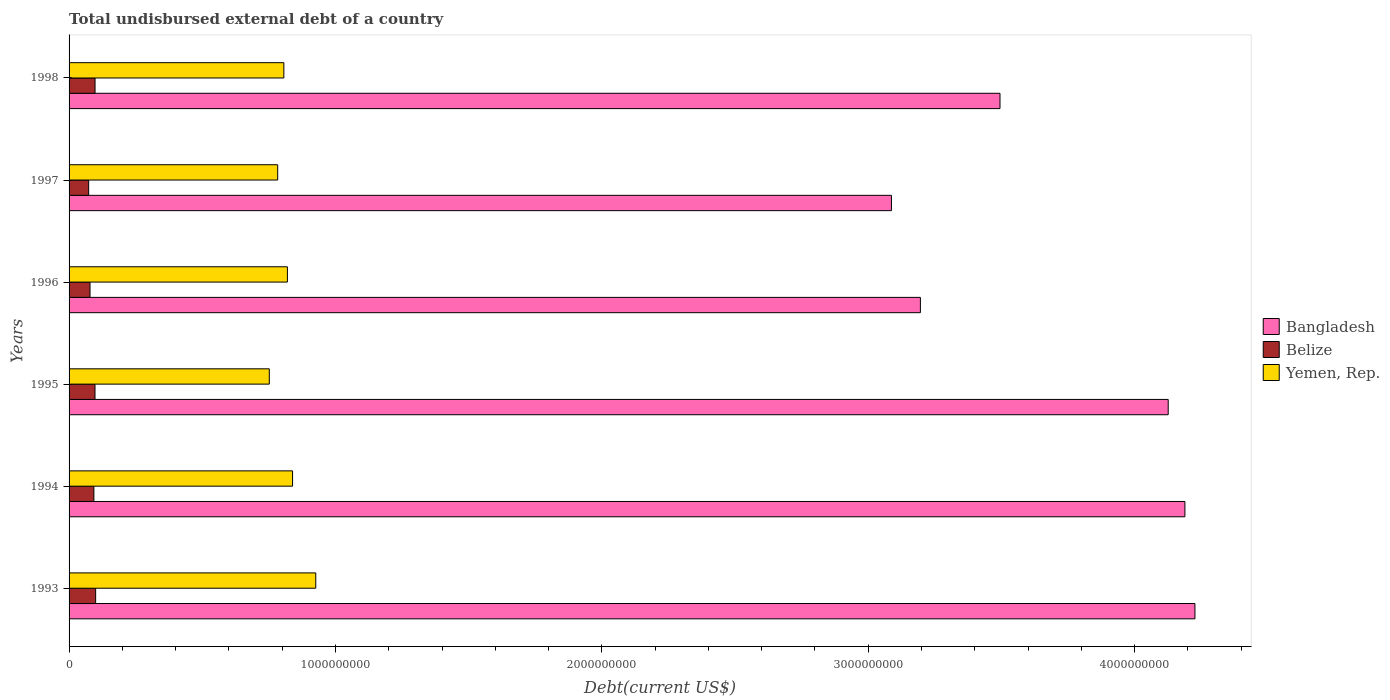How many different coloured bars are there?
Your answer should be very brief. 3. How many groups of bars are there?
Offer a terse response. 6. How many bars are there on the 3rd tick from the top?
Make the answer very short. 3. What is the total undisbursed external debt in Belize in 1998?
Provide a succinct answer. 9.75e+07. Across all years, what is the maximum total undisbursed external debt in Bangladesh?
Offer a terse response. 4.23e+09. Across all years, what is the minimum total undisbursed external debt in Yemen, Rep.?
Your answer should be compact. 7.52e+08. In which year was the total undisbursed external debt in Yemen, Rep. minimum?
Your response must be concise. 1995. What is the total total undisbursed external debt in Belize in the graph?
Ensure brevity in your answer.  5.40e+08. What is the difference between the total undisbursed external debt in Belize in 1994 and that in 1997?
Your response must be concise. 1.96e+07. What is the difference between the total undisbursed external debt in Yemen, Rep. in 1994 and the total undisbursed external debt in Belize in 1995?
Your answer should be compact. 7.42e+08. What is the average total undisbursed external debt in Belize per year?
Offer a terse response. 9.00e+07. In the year 1995, what is the difference between the total undisbursed external debt in Bangladesh and total undisbursed external debt in Belize?
Offer a very short reply. 4.03e+09. In how many years, is the total undisbursed external debt in Belize greater than 4200000000 US$?
Provide a short and direct response. 0. What is the ratio of the total undisbursed external debt in Yemen, Rep. in 1996 to that in 1998?
Your response must be concise. 1.02. Is the total undisbursed external debt in Bangladesh in 1996 less than that in 1998?
Offer a terse response. Yes. Is the difference between the total undisbursed external debt in Bangladesh in 1995 and 1997 greater than the difference between the total undisbursed external debt in Belize in 1995 and 1997?
Offer a very short reply. Yes. What is the difference between the highest and the second highest total undisbursed external debt in Bangladesh?
Ensure brevity in your answer.  3.77e+07. What is the difference between the highest and the lowest total undisbursed external debt in Yemen, Rep.?
Your answer should be compact. 1.74e+08. In how many years, is the total undisbursed external debt in Belize greater than the average total undisbursed external debt in Belize taken over all years?
Your response must be concise. 4. Is the sum of the total undisbursed external debt in Bangladesh in 1996 and 1998 greater than the maximum total undisbursed external debt in Belize across all years?
Ensure brevity in your answer.  Yes. What does the 1st bar from the top in 1995 represents?
Provide a succinct answer. Yemen, Rep. What does the 3rd bar from the bottom in 1997 represents?
Give a very brief answer. Yemen, Rep. How many bars are there?
Keep it short and to the point. 18. Are all the bars in the graph horizontal?
Ensure brevity in your answer.  Yes. How many years are there in the graph?
Give a very brief answer. 6. What is the difference between two consecutive major ticks on the X-axis?
Offer a terse response. 1.00e+09. Are the values on the major ticks of X-axis written in scientific E-notation?
Make the answer very short. No. Where does the legend appear in the graph?
Your answer should be very brief. Center right. How many legend labels are there?
Offer a terse response. 3. What is the title of the graph?
Ensure brevity in your answer.  Total undisbursed external debt of a country. Does "Madagascar" appear as one of the legend labels in the graph?
Offer a very short reply. No. What is the label or title of the X-axis?
Provide a succinct answer. Debt(current US$). What is the label or title of the Y-axis?
Provide a succinct answer. Years. What is the Debt(current US$) of Bangladesh in 1993?
Offer a terse response. 4.23e+09. What is the Debt(current US$) in Belize in 1993?
Your response must be concise. 9.97e+07. What is the Debt(current US$) of Yemen, Rep. in 1993?
Provide a succinct answer. 9.26e+08. What is the Debt(current US$) in Bangladesh in 1994?
Ensure brevity in your answer.  4.19e+09. What is the Debt(current US$) of Belize in 1994?
Your response must be concise. 9.31e+07. What is the Debt(current US$) in Yemen, Rep. in 1994?
Offer a very short reply. 8.39e+08. What is the Debt(current US$) in Bangladesh in 1995?
Your answer should be very brief. 4.13e+09. What is the Debt(current US$) in Belize in 1995?
Your response must be concise. 9.73e+07. What is the Debt(current US$) of Yemen, Rep. in 1995?
Provide a short and direct response. 7.52e+08. What is the Debt(current US$) of Bangladesh in 1996?
Offer a terse response. 3.20e+09. What is the Debt(current US$) of Belize in 1996?
Offer a terse response. 7.87e+07. What is the Debt(current US$) of Yemen, Rep. in 1996?
Offer a very short reply. 8.20e+08. What is the Debt(current US$) in Bangladesh in 1997?
Offer a terse response. 3.09e+09. What is the Debt(current US$) in Belize in 1997?
Keep it short and to the point. 7.35e+07. What is the Debt(current US$) of Yemen, Rep. in 1997?
Give a very brief answer. 7.83e+08. What is the Debt(current US$) in Bangladesh in 1998?
Your answer should be compact. 3.49e+09. What is the Debt(current US$) in Belize in 1998?
Provide a succinct answer. 9.75e+07. What is the Debt(current US$) in Yemen, Rep. in 1998?
Make the answer very short. 8.06e+08. Across all years, what is the maximum Debt(current US$) in Bangladesh?
Your response must be concise. 4.23e+09. Across all years, what is the maximum Debt(current US$) of Belize?
Make the answer very short. 9.97e+07. Across all years, what is the maximum Debt(current US$) of Yemen, Rep.?
Keep it short and to the point. 9.26e+08. Across all years, what is the minimum Debt(current US$) in Bangladesh?
Provide a short and direct response. 3.09e+09. Across all years, what is the minimum Debt(current US$) of Belize?
Ensure brevity in your answer.  7.35e+07. Across all years, what is the minimum Debt(current US$) in Yemen, Rep.?
Your answer should be very brief. 7.52e+08. What is the total Debt(current US$) in Bangladesh in the graph?
Your answer should be compact. 2.23e+1. What is the total Debt(current US$) in Belize in the graph?
Ensure brevity in your answer.  5.40e+08. What is the total Debt(current US$) in Yemen, Rep. in the graph?
Provide a short and direct response. 4.93e+09. What is the difference between the Debt(current US$) in Bangladesh in 1993 and that in 1994?
Offer a terse response. 3.77e+07. What is the difference between the Debt(current US$) in Belize in 1993 and that in 1994?
Offer a terse response. 6.62e+06. What is the difference between the Debt(current US$) of Yemen, Rep. in 1993 and that in 1994?
Give a very brief answer. 8.71e+07. What is the difference between the Debt(current US$) in Bangladesh in 1993 and that in 1995?
Ensure brevity in your answer.  1.00e+08. What is the difference between the Debt(current US$) in Belize in 1993 and that in 1995?
Keep it short and to the point. 2.42e+06. What is the difference between the Debt(current US$) in Yemen, Rep. in 1993 and that in 1995?
Offer a very short reply. 1.74e+08. What is the difference between the Debt(current US$) of Bangladesh in 1993 and that in 1996?
Keep it short and to the point. 1.03e+09. What is the difference between the Debt(current US$) of Belize in 1993 and that in 1996?
Keep it short and to the point. 2.11e+07. What is the difference between the Debt(current US$) of Yemen, Rep. in 1993 and that in 1996?
Provide a succinct answer. 1.06e+08. What is the difference between the Debt(current US$) of Bangladesh in 1993 and that in 1997?
Provide a short and direct response. 1.14e+09. What is the difference between the Debt(current US$) of Belize in 1993 and that in 1997?
Your response must be concise. 2.62e+07. What is the difference between the Debt(current US$) in Yemen, Rep. in 1993 and that in 1997?
Ensure brevity in your answer.  1.43e+08. What is the difference between the Debt(current US$) in Bangladesh in 1993 and that in 1998?
Offer a very short reply. 7.32e+08. What is the difference between the Debt(current US$) in Belize in 1993 and that in 1998?
Ensure brevity in your answer.  2.23e+06. What is the difference between the Debt(current US$) of Yemen, Rep. in 1993 and that in 1998?
Your answer should be very brief. 1.20e+08. What is the difference between the Debt(current US$) of Bangladesh in 1994 and that in 1995?
Your response must be concise. 6.27e+07. What is the difference between the Debt(current US$) of Belize in 1994 and that in 1995?
Your answer should be very brief. -4.20e+06. What is the difference between the Debt(current US$) of Yemen, Rep. in 1994 and that in 1995?
Provide a succinct answer. 8.74e+07. What is the difference between the Debt(current US$) of Bangladesh in 1994 and that in 1996?
Ensure brevity in your answer.  9.93e+08. What is the difference between the Debt(current US$) of Belize in 1994 and that in 1996?
Ensure brevity in your answer.  1.45e+07. What is the difference between the Debt(current US$) of Yemen, Rep. in 1994 and that in 1996?
Offer a terse response. 1.94e+07. What is the difference between the Debt(current US$) in Bangladesh in 1994 and that in 1997?
Provide a succinct answer. 1.10e+09. What is the difference between the Debt(current US$) in Belize in 1994 and that in 1997?
Your answer should be very brief. 1.96e+07. What is the difference between the Debt(current US$) of Yemen, Rep. in 1994 and that in 1997?
Your answer should be compact. 5.59e+07. What is the difference between the Debt(current US$) of Bangladesh in 1994 and that in 1998?
Provide a succinct answer. 6.94e+08. What is the difference between the Debt(current US$) in Belize in 1994 and that in 1998?
Your response must be concise. -4.39e+06. What is the difference between the Debt(current US$) in Yemen, Rep. in 1994 and that in 1998?
Make the answer very short. 3.27e+07. What is the difference between the Debt(current US$) of Bangladesh in 1995 and that in 1996?
Give a very brief answer. 9.30e+08. What is the difference between the Debt(current US$) in Belize in 1995 and that in 1996?
Your response must be concise. 1.87e+07. What is the difference between the Debt(current US$) of Yemen, Rep. in 1995 and that in 1996?
Offer a terse response. -6.80e+07. What is the difference between the Debt(current US$) of Bangladesh in 1995 and that in 1997?
Make the answer very short. 1.04e+09. What is the difference between the Debt(current US$) of Belize in 1995 and that in 1997?
Your answer should be very brief. 2.38e+07. What is the difference between the Debt(current US$) in Yemen, Rep. in 1995 and that in 1997?
Your answer should be very brief. -3.15e+07. What is the difference between the Debt(current US$) of Bangladesh in 1995 and that in 1998?
Your answer should be very brief. 6.31e+08. What is the difference between the Debt(current US$) of Belize in 1995 and that in 1998?
Provide a succinct answer. -1.91e+05. What is the difference between the Debt(current US$) in Yemen, Rep. in 1995 and that in 1998?
Keep it short and to the point. -5.47e+07. What is the difference between the Debt(current US$) in Bangladesh in 1996 and that in 1997?
Make the answer very short. 1.09e+08. What is the difference between the Debt(current US$) of Belize in 1996 and that in 1997?
Provide a succinct answer. 5.10e+06. What is the difference between the Debt(current US$) of Yemen, Rep. in 1996 and that in 1997?
Your answer should be compact. 3.65e+07. What is the difference between the Debt(current US$) in Bangladesh in 1996 and that in 1998?
Keep it short and to the point. -2.99e+08. What is the difference between the Debt(current US$) of Belize in 1996 and that in 1998?
Keep it short and to the point. -1.89e+07. What is the difference between the Debt(current US$) in Yemen, Rep. in 1996 and that in 1998?
Give a very brief answer. 1.33e+07. What is the difference between the Debt(current US$) in Bangladesh in 1997 and that in 1998?
Your answer should be very brief. -4.07e+08. What is the difference between the Debt(current US$) of Belize in 1997 and that in 1998?
Offer a very short reply. -2.40e+07. What is the difference between the Debt(current US$) of Yemen, Rep. in 1997 and that in 1998?
Offer a terse response. -2.32e+07. What is the difference between the Debt(current US$) in Bangladesh in 1993 and the Debt(current US$) in Belize in 1994?
Your answer should be compact. 4.13e+09. What is the difference between the Debt(current US$) of Bangladesh in 1993 and the Debt(current US$) of Yemen, Rep. in 1994?
Give a very brief answer. 3.39e+09. What is the difference between the Debt(current US$) of Belize in 1993 and the Debt(current US$) of Yemen, Rep. in 1994?
Offer a very short reply. -7.39e+08. What is the difference between the Debt(current US$) in Bangladesh in 1993 and the Debt(current US$) in Belize in 1995?
Your answer should be very brief. 4.13e+09. What is the difference between the Debt(current US$) of Bangladesh in 1993 and the Debt(current US$) of Yemen, Rep. in 1995?
Offer a terse response. 3.47e+09. What is the difference between the Debt(current US$) in Belize in 1993 and the Debt(current US$) in Yemen, Rep. in 1995?
Make the answer very short. -6.52e+08. What is the difference between the Debt(current US$) of Bangladesh in 1993 and the Debt(current US$) of Belize in 1996?
Provide a succinct answer. 4.15e+09. What is the difference between the Debt(current US$) in Bangladesh in 1993 and the Debt(current US$) in Yemen, Rep. in 1996?
Your response must be concise. 3.41e+09. What is the difference between the Debt(current US$) in Belize in 1993 and the Debt(current US$) in Yemen, Rep. in 1996?
Make the answer very short. -7.20e+08. What is the difference between the Debt(current US$) in Bangladesh in 1993 and the Debt(current US$) in Belize in 1997?
Your answer should be compact. 4.15e+09. What is the difference between the Debt(current US$) of Bangladesh in 1993 and the Debt(current US$) of Yemen, Rep. in 1997?
Keep it short and to the point. 3.44e+09. What is the difference between the Debt(current US$) in Belize in 1993 and the Debt(current US$) in Yemen, Rep. in 1997?
Provide a short and direct response. -6.83e+08. What is the difference between the Debt(current US$) in Bangladesh in 1993 and the Debt(current US$) in Belize in 1998?
Provide a succinct answer. 4.13e+09. What is the difference between the Debt(current US$) in Bangladesh in 1993 and the Debt(current US$) in Yemen, Rep. in 1998?
Keep it short and to the point. 3.42e+09. What is the difference between the Debt(current US$) of Belize in 1993 and the Debt(current US$) of Yemen, Rep. in 1998?
Provide a succinct answer. -7.07e+08. What is the difference between the Debt(current US$) of Bangladesh in 1994 and the Debt(current US$) of Belize in 1995?
Provide a short and direct response. 4.09e+09. What is the difference between the Debt(current US$) of Bangladesh in 1994 and the Debt(current US$) of Yemen, Rep. in 1995?
Provide a short and direct response. 3.44e+09. What is the difference between the Debt(current US$) in Belize in 1994 and the Debt(current US$) in Yemen, Rep. in 1995?
Your answer should be very brief. -6.59e+08. What is the difference between the Debt(current US$) in Bangladesh in 1994 and the Debt(current US$) in Belize in 1996?
Your response must be concise. 4.11e+09. What is the difference between the Debt(current US$) in Bangladesh in 1994 and the Debt(current US$) in Yemen, Rep. in 1996?
Offer a terse response. 3.37e+09. What is the difference between the Debt(current US$) in Belize in 1994 and the Debt(current US$) in Yemen, Rep. in 1996?
Keep it short and to the point. -7.27e+08. What is the difference between the Debt(current US$) in Bangladesh in 1994 and the Debt(current US$) in Belize in 1997?
Provide a short and direct response. 4.12e+09. What is the difference between the Debt(current US$) of Bangladesh in 1994 and the Debt(current US$) of Yemen, Rep. in 1997?
Provide a succinct answer. 3.41e+09. What is the difference between the Debt(current US$) of Belize in 1994 and the Debt(current US$) of Yemen, Rep. in 1997?
Make the answer very short. -6.90e+08. What is the difference between the Debt(current US$) of Bangladesh in 1994 and the Debt(current US$) of Belize in 1998?
Make the answer very short. 4.09e+09. What is the difference between the Debt(current US$) of Bangladesh in 1994 and the Debt(current US$) of Yemen, Rep. in 1998?
Give a very brief answer. 3.38e+09. What is the difference between the Debt(current US$) of Belize in 1994 and the Debt(current US$) of Yemen, Rep. in 1998?
Your response must be concise. -7.13e+08. What is the difference between the Debt(current US$) of Bangladesh in 1995 and the Debt(current US$) of Belize in 1996?
Your response must be concise. 4.05e+09. What is the difference between the Debt(current US$) of Bangladesh in 1995 and the Debt(current US$) of Yemen, Rep. in 1996?
Provide a succinct answer. 3.31e+09. What is the difference between the Debt(current US$) in Belize in 1995 and the Debt(current US$) in Yemen, Rep. in 1996?
Your answer should be very brief. -7.22e+08. What is the difference between the Debt(current US$) of Bangladesh in 1995 and the Debt(current US$) of Belize in 1997?
Your answer should be very brief. 4.05e+09. What is the difference between the Debt(current US$) of Bangladesh in 1995 and the Debt(current US$) of Yemen, Rep. in 1997?
Provide a short and direct response. 3.34e+09. What is the difference between the Debt(current US$) in Belize in 1995 and the Debt(current US$) in Yemen, Rep. in 1997?
Keep it short and to the point. -6.86e+08. What is the difference between the Debt(current US$) in Bangladesh in 1995 and the Debt(current US$) in Belize in 1998?
Keep it short and to the point. 4.03e+09. What is the difference between the Debt(current US$) of Bangladesh in 1995 and the Debt(current US$) of Yemen, Rep. in 1998?
Your response must be concise. 3.32e+09. What is the difference between the Debt(current US$) in Belize in 1995 and the Debt(current US$) in Yemen, Rep. in 1998?
Offer a terse response. -7.09e+08. What is the difference between the Debt(current US$) of Bangladesh in 1996 and the Debt(current US$) of Belize in 1997?
Offer a terse response. 3.12e+09. What is the difference between the Debt(current US$) of Bangladesh in 1996 and the Debt(current US$) of Yemen, Rep. in 1997?
Your answer should be very brief. 2.41e+09. What is the difference between the Debt(current US$) in Belize in 1996 and the Debt(current US$) in Yemen, Rep. in 1997?
Make the answer very short. -7.05e+08. What is the difference between the Debt(current US$) of Bangladesh in 1996 and the Debt(current US$) of Belize in 1998?
Ensure brevity in your answer.  3.10e+09. What is the difference between the Debt(current US$) of Bangladesh in 1996 and the Debt(current US$) of Yemen, Rep. in 1998?
Give a very brief answer. 2.39e+09. What is the difference between the Debt(current US$) of Belize in 1996 and the Debt(current US$) of Yemen, Rep. in 1998?
Your answer should be compact. -7.28e+08. What is the difference between the Debt(current US$) of Bangladesh in 1997 and the Debt(current US$) of Belize in 1998?
Keep it short and to the point. 2.99e+09. What is the difference between the Debt(current US$) of Bangladesh in 1997 and the Debt(current US$) of Yemen, Rep. in 1998?
Your answer should be compact. 2.28e+09. What is the difference between the Debt(current US$) in Belize in 1997 and the Debt(current US$) in Yemen, Rep. in 1998?
Make the answer very short. -7.33e+08. What is the average Debt(current US$) in Bangladesh per year?
Ensure brevity in your answer.  3.72e+09. What is the average Debt(current US$) of Belize per year?
Keep it short and to the point. 9.00e+07. What is the average Debt(current US$) in Yemen, Rep. per year?
Offer a very short reply. 8.21e+08. In the year 1993, what is the difference between the Debt(current US$) of Bangladesh and Debt(current US$) of Belize?
Provide a succinct answer. 4.13e+09. In the year 1993, what is the difference between the Debt(current US$) of Bangladesh and Debt(current US$) of Yemen, Rep.?
Make the answer very short. 3.30e+09. In the year 1993, what is the difference between the Debt(current US$) in Belize and Debt(current US$) in Yemen, Rep.?
Your answer should be very brief. -8.26e+08. In the year 1994, what is the difference between the Debt(current US$) in Bangladesh and Debt(current US$) in Belize?
Give a very brief answer. 4.10e+09. In the year 1994, what is the difference between the Debt(current US$) in Bangladesh and Debt(current US$) in Yemen, Rep.?
Give a very brief answer. 3.35e+09. In the year 1994, what is the difference between the Debt(current US$) in Belize and Debt(current US$) in Yemen, Rep.?
Provide a succinct answer. -7.46e+08. In the year 1995, what is the difference between the Debt(current US$) in Bangladesh and Debt(current US$) in Belize?
Give a very brief answer. 4.03e+09. In the year 1995, what is the difference between the Debt(current US$) of Bangladesh and Debt(current US$) of Yemen, Rep.?
Offer a terse response. 3.37e+09. In the year 1995, what is the difference between the Debt(current US$) in Belize and Debt(current US$) in Yemen, Rep.?
Provide a succinct answer. -6.54e+08. In the year 1996, what is the difference between the Debt(current US$) in Bangladesh and Debt(current US$) in Belize?
Offer a terse response. 3.12e+09. In the year 1996, what is the difference between the Debt(current US$) in Bangladesh and Debt(current US$) in Yemen, Rep.?
Give a very brief answer. 2.38e+09. In the year 1996, what is the difference between the Debt(current US$) of Belize and Debt(current US$) of Yemen, Rep.?
Your answer should be very brief. -7.41e+08. In the year 1997, what is the difference between the Debt(current US$) in Bangladesh and Debt(current US$) in Belize?
Provide a succinct answer. 3.01e+09. In the year 1997, what is the difference between the Debt(current US$) in Bangladesh and Debt(current US$) in Yemen, Rep.?
Your answer should be very brief. 2.30e+09. In the year 1997, what is the difference between the Debt(current US$) of Belize and Debt(current US$) of Yemen, Rep.?
Offer a terse response. -7.10e+08. In the year 1998, what is the difference between the Debt(current US$) in Bangladesh and Debt(current US$) in Belize?
Provide a short and direct response. 3.40e+09. In the year 1998, what is the difference between the Debt(current US$) of Bangladesh and Debt(current US$) of Yemen, Rep.?
Offer a very short reply. 2.69e+09. In the year 1998, what is the difference between the Debt(current US$) of Belize and Debt(current US$) of Yemen, Rep.?
Your answer should be compact. -7.09e+08. What is the ratio of the Debt(current US$) in Bangladesh in 1993 to that in 1994?
Offer a terse response. 1.01. What is the ratio of the Debt(current US$) of Belize in 1993 to that in 1994?
Ensure brevity in your answer.  1.07. What is the ratio of the Debt(current US$) of Yemen, Rep. in 1993 to that in 1994?
Offer a terse response. 1.1. What is the ratio of the Debt(current US$) of Bangladesh in 1993 to that in 1995?
Give a very brief answer. 1.02. What is the ratio of the Debt(current US$) of Belize in 1993 to that in 1995?
Keep it short and to the point. 1.02. What is the ratio of the Debt(current US$) of Yemen, Rep. in 1993 to that in 1995?
Your answer should be compact. 1.23. What is the ratio of the Debt(current US$) in Bangladesh in 1993 to that in 1996?
Provide a succinct answer. 1.32. What is the ratio of the Debt(current US$) of Belize in 1993 to that in 1996?
Your answer should be very brief. 1.27. What is the ratio of the Debt(current US$) of Yemen, Rep. in 1993 to that in 1996?
Your answer should be very brief. 1.13. What is the ratio of the Debt(current US$) of Bangladesh in 1993 to that in 1997?
Your answer should be compact. 1.37. What is the ratio of the Debt(current US$) of Belize in 1993 to that in 1997?
Give a very brief answer. 1.36. What is the ratio of the Debt(current US$) of Yemen, Rep. in 1993 to that in 1997?
Your response must be concise. 1.18. What is the ratio of the Debt(current US$) of Bangladesh in 1993 to that in 1998?
Offer a terse response. 1.21. What is the ratio of the Debt(current US$) in Belize in 1993 to that in 1998?
Keep it short and to the point. 1.02. What is the ratio of the Debt(current US$) of Yemen, Rep. in 1993 to that in 1998?
Provide a succinct answer. 1.15. What is the ratio of the Debt(current US$) of Bangladesh in 1994 to that in 1995?
Your answer should be compact. 1.02. What is the ratio of the Debt(current US$) in Belize in 1994 to that in 1995?
Offer a terse response. 0.96. What is the ratio of the Debt(current US$) in Yemen, Rep. in 1994 to that in 1995?
Offer a very short reply. 1.12. What is the ratio of the Debt(current US$) in Bangladesh in 1994 to that in 1996?
Ensure brevity in your answer.  1.31. What is the ratio of the Debt(current US$) in Belize in 1994 to that in 1996?
Make the answer very short. 1.18. What is the ratio of the Debt(current US$) of Yemen, Rep. in 1994 to that in 1996?
Offer a terse response. 1.02. What is the ratio of the Debt(current US$) of Bangladesh in 1994 to that in 1997?
Offer a very short reply. 1.36. What is the ratio of the Debt(current US$) of Belize in 1994 to that in 1997?
Make the answer very short. 1.27. What is the ratio of the Debt(current US$) in Yemen, Rep. in 1994 to that in 1997?
Offer a very short reply. 1.07. What is the ratio of the Debt(current US$) in Bangladesh in 1994 to that in 1998?
Ensure brevity in your answer.  1.2. What is the ratio of the Debt(current US$) in Belize in 1994 to that in 1998?
Your answer should be compact. 0.95. What is the ratio of the Debt(current US$) in Yemen, Rep. in 1994 to that in 1998?
Ensure brevity in your answer.  1.04. What is the ratio of the Debt(current US$) of Bangladesh in 1995 to that in 1996?
Give a very brief answer. 1.29. What is the ratio of the Debt(current US$) of Belize in 1995 to that in 1996?
Give a very brief answer. 1.24. What is the ratio of the Debt(current US$) in Yemen, Rep. in 1995 to that in 1996?
Your answer should be very brief. 0.92. What is the ratio of the Debt(current US$) of Bangladesh in 1995 to that in 1997?
Your answer should be compact. 1.34. What is the ratio of the Debt(current US$) of Belize in 1995 to that in 1997?
Your response must be concise. 1.32. What is the ratio of the Debt(current US$) of Yemen, Rep. in 1995 to that in 1997?
Provide a succinct answer. 0.96. What is the ratio of the Debt(current US$) in Bangladesh in 1995 to that in 1998?
Your answer should be compact. 1.18. What is the ratio of the Debt(current US$) in Yemen, Rep. in 1995 to that in 1998?
Make the answer very short. 0.93. What is the ratio of the Debt(current US$) of Bangladesh in 1996 to that in 1997?
Offer a terse response. 1.04. What is the ratio of the Debt(current US$) of Belize in 1996 to that in 1997?
Offer a terse response. 1.07. What is the ratio of the Debt(current US$) of Yemen, Rep. in 1996 to that in 1997?
Keep it short and to the point. 1.05. What is the ratio of the Debt(current US$) of Bangladesh in 1996 to that in 1998?
Your response must be concise. 0.91. What is the ratio of the Debt(current US$) of Belize in 1996 to that in 1998?
Offer a very short reply. 0.81. What is the ratio of the Debt(current US$) of Yemen, Rep. in 1996 to that in 1998?
Offer a terse response. 1.02. What is the ratio of the Debt(current US$) in Bangladesh in 1997 to that in 1998?
Provide a succinct answer. 0.88. What is the ratio of the Debt(current US$) of Belize in 1997 to that in 1998?
Ensure brevity in your answer.  0.75. What is the ratio of the Debt(current US$) of Yemen, Rep. in 1997 to that in 1998?
Offer a very short reply. 0.97. What is the difference between the highest and the second highest Debt(current US$) in Bangladesh?
Offer a very short reply. 3.77e+07. What is the difference between the highest and the second highest Debt(current US$) in Belize?
Your response must be concise. 2.23e+06. What is the difference between the highest and the second highest Debt(current US$) of Yemen, Rep.?
Make the answer very short. 8.71e+07. What is the difference between the highest and the lowest Debt(current US$) in Bangladesh?
Your answer should be compact. 1.14e+09. What is the difference between the highest and the lowest Debt(current US$) in Belize?
Offer a very short reply. 2.62e+07. What is the difference between the highest and the lowest Debt(current US$) of Yemen, Rep.?
Offer a very short reply. 1.74e+08. 